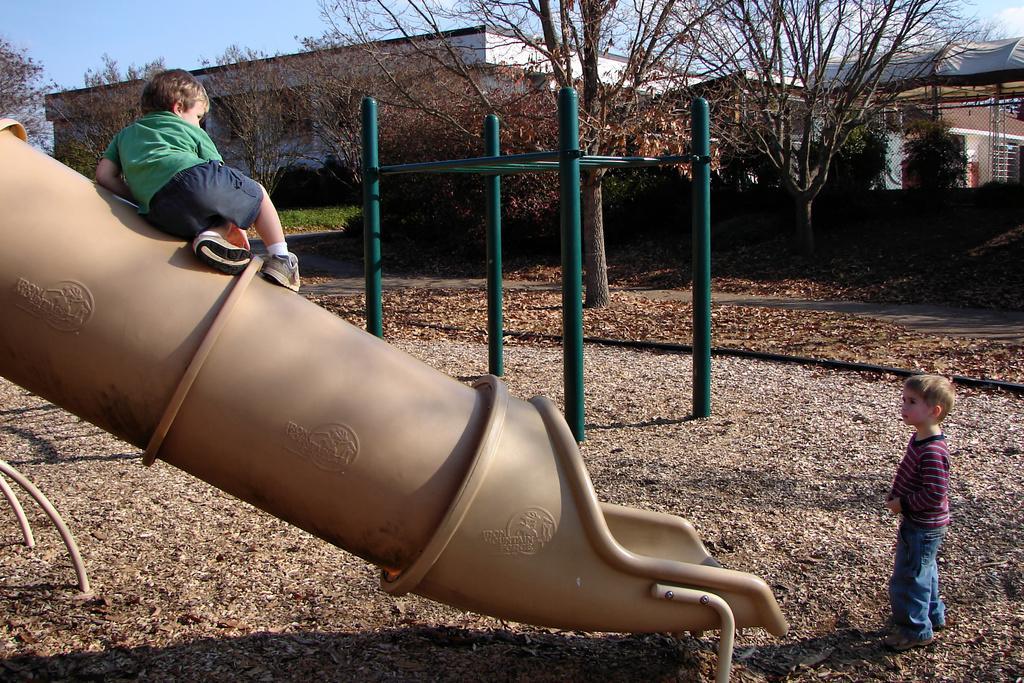Can you describe this image briefly? In the image we can see two children, wearing clothes and shoes. This is dry grass, pole, trees, buildings, grass, path and a pale blue sky. 